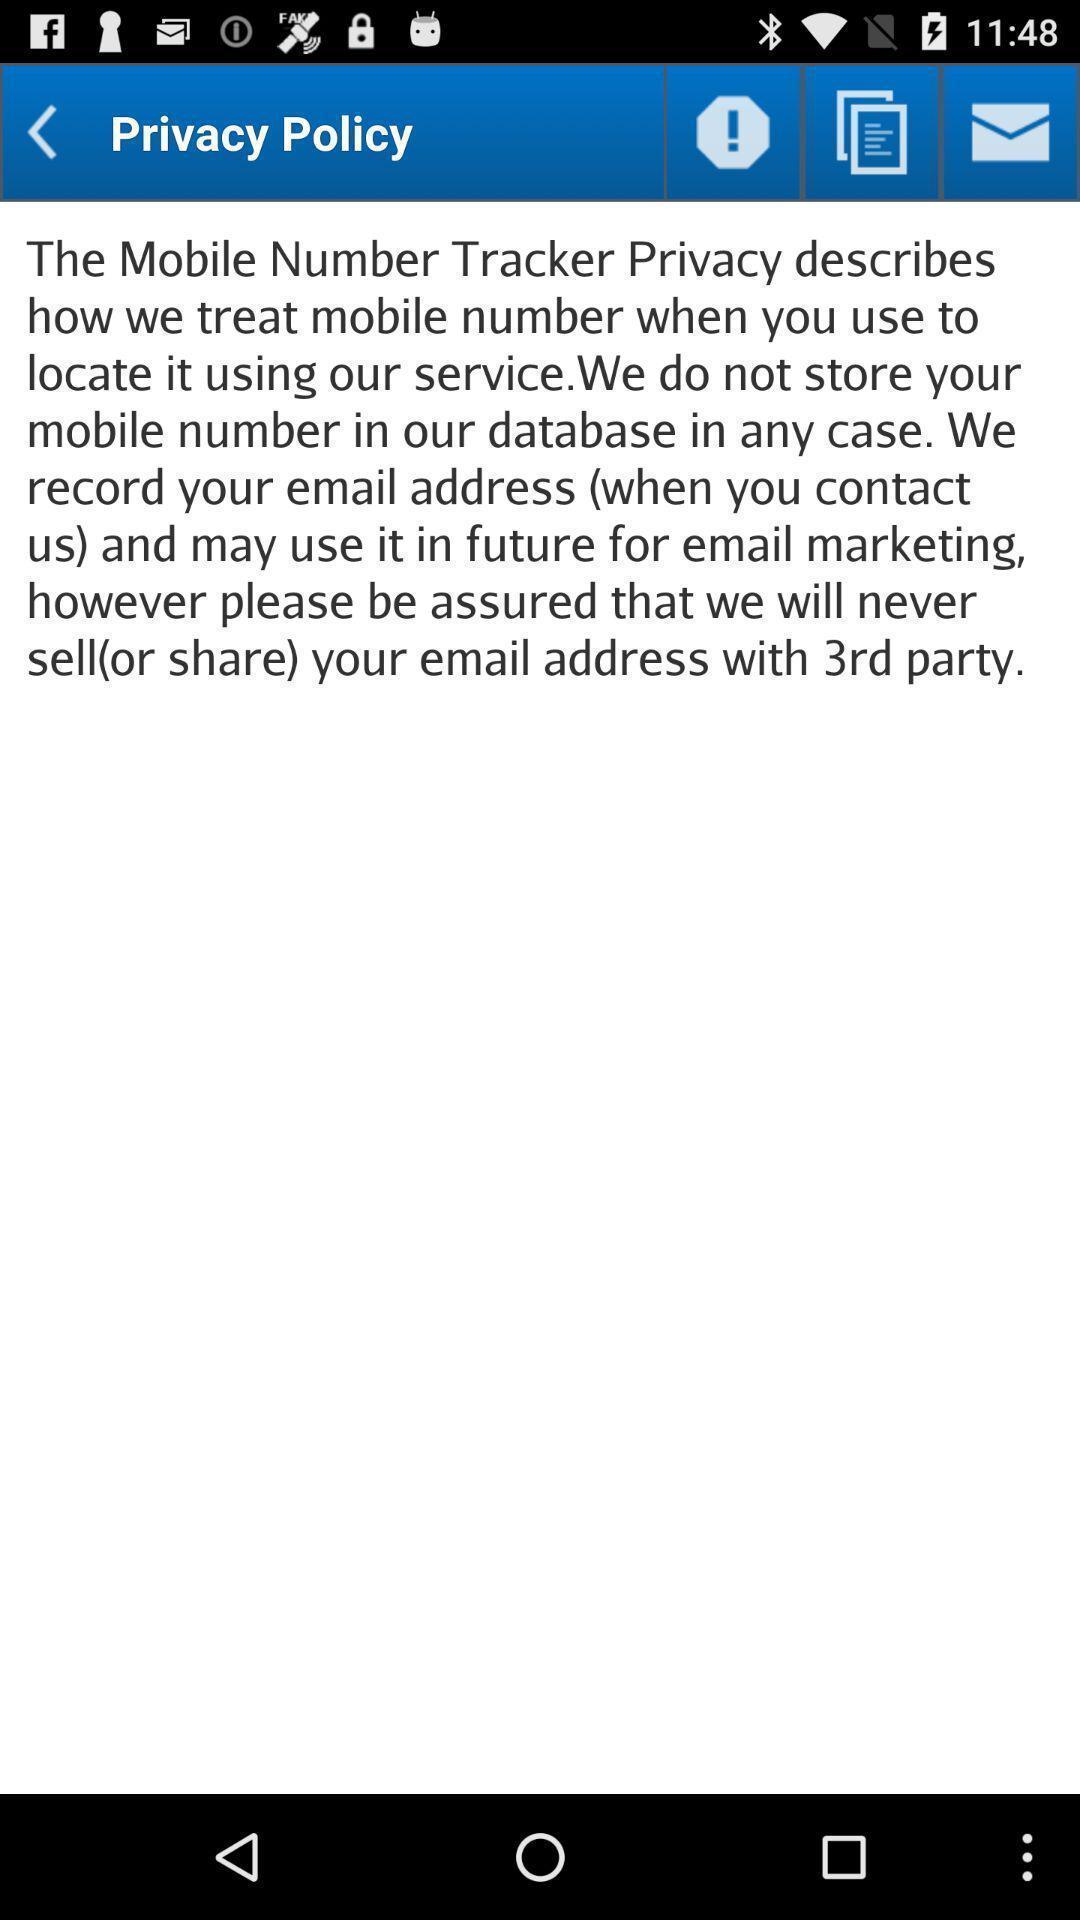Provide a description of this screenshot. Page shows the privacy policy information on app. 